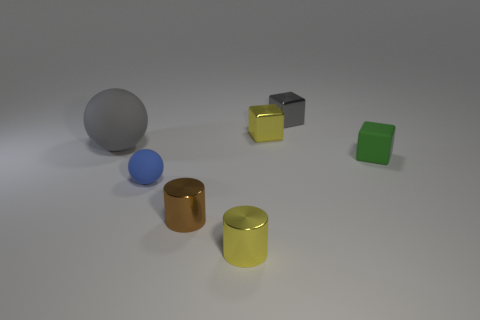How many other objects are the same material as the tiny sphere?
Offer a terse response. 2. What is the material of the large object?
Keep it short and to the point. Rubber. Do the tiny shiny cylinder that is on the left side of the yellow metallic cylinder and the cube in front of the gray ball have the same color?
Make the answer very short. No. Are there more rubber spheres on the left side of the gray sphere than large spheres?
Your answer should be very brief. No. How many other objects are there of the same color as the big ball?
Your response must be concise. 1. Does the yellow object in front of the yellow shiny cube have the same size as the tiny gray block?
Offer a very short reply. Yes. Are there any green matte objects of the same size as the brown cylinder?
Give a very brief answer. Yes. There is a small sphere in front of the gray rubber ball; what color is it?
Keep it short and to the point. Blue. What shape is the matte thing that is left of the small yellow metallic block and right of the big matte ball?
Your answer should be compact. Sphere. What number of small yellow objects have the same shape as the tiny green thing?
Offer a very short reply. 1. 